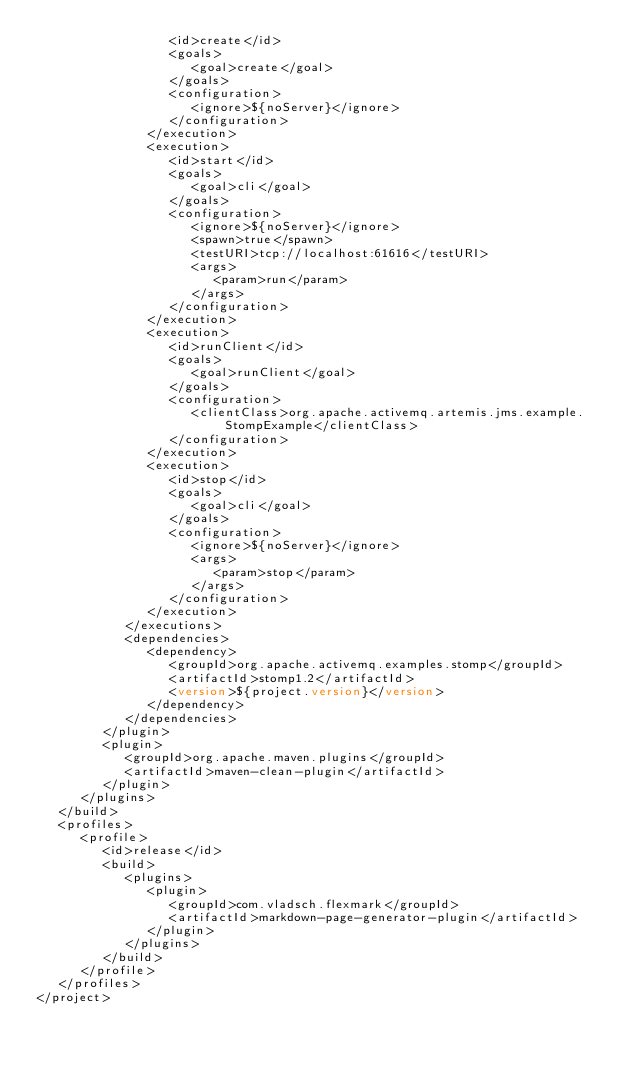<code> <loc_0><loc_0><loc_500><loc_500><_XML_>                  <id>create</id>
                  <goals>
                     <goal>create</goal>
                  </goals>
                  <configuration>
                     <ignore>${noServer}</ignore>
                  </configuration>
               </execution>
               <execution>
                  <id>start</id>
                  <goals>
                     <goal>cli</goal>
                  </goals>
                  <configuration>
                     <ignore>${noServer}</ignore>
                     <spawn>true</spawn>
                     <testURI>tcp://localhost:61616</testURI>
                     <args>
                        <param>run</param>
                     </args>
                  </configuration>
               </execution>
               <execution>
                  <id>runClient</id>
                  <goals>
                     <goal>runClient</goal>
                  </goals>
                  <configuration>
                     <clientClass>org.apache.activemq.artemis.jms.example.StompExample</clientClass>
                  </configuration>
               </execution>
               <execution>
                  <id>stop</id>
                  <goals>
                     <goal>cli</goal>
                  </goals>
                  <configuration>
                     <ignore>${noServer}</ignore>
                     <args>
                        <param>stop</param>
                     </args>
                  </configuration>
               </execution>
            </executions>
            <dependencies>
               <dependency>
                  <groupId>org.apache.activemq.examples.stomp</groupId>
                  <artifactId>stomp1.2</artifactId>
                  <version>${project.version}</version>
               </dependency>
            </dependencies>
         </plugin>
         <plugin>
            <groupId>org.apache.maven.plugins</groupId>
            <artifactId>maven-clean-plugin</artifactId>
         </plugin>
      </plugins>
   </build>
   <profiles>
      <profile>
         <id>release</id>
         <build>
            <plugins>
               <plugin>
                  <groupId>com.vladsch.flexmark</groupId>
                  <artifactId>markdown-page-generator-plugin</artifactId>
               </plugin>
            </plugins>
         </build>
      </profile>
   </profiles>
</project></code> 